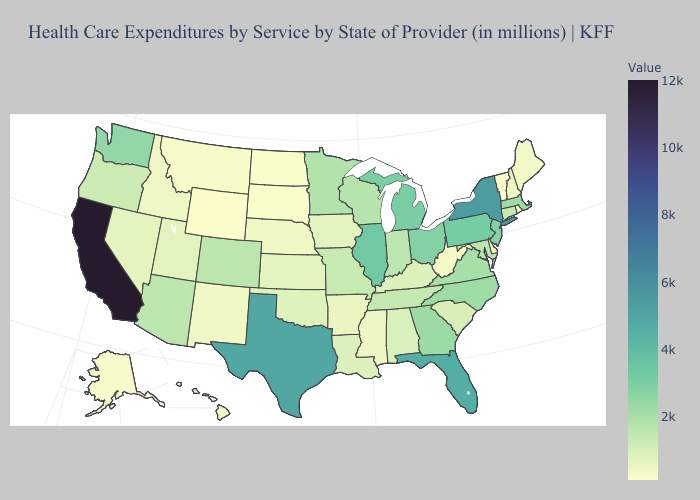Does California have the highest value in the USA?
Give a very brief answer. Yes. Does the map have missing data?
Answer briefly. No. Does New York have the highest value in the Northeast?
Keep it brief. Yes. 